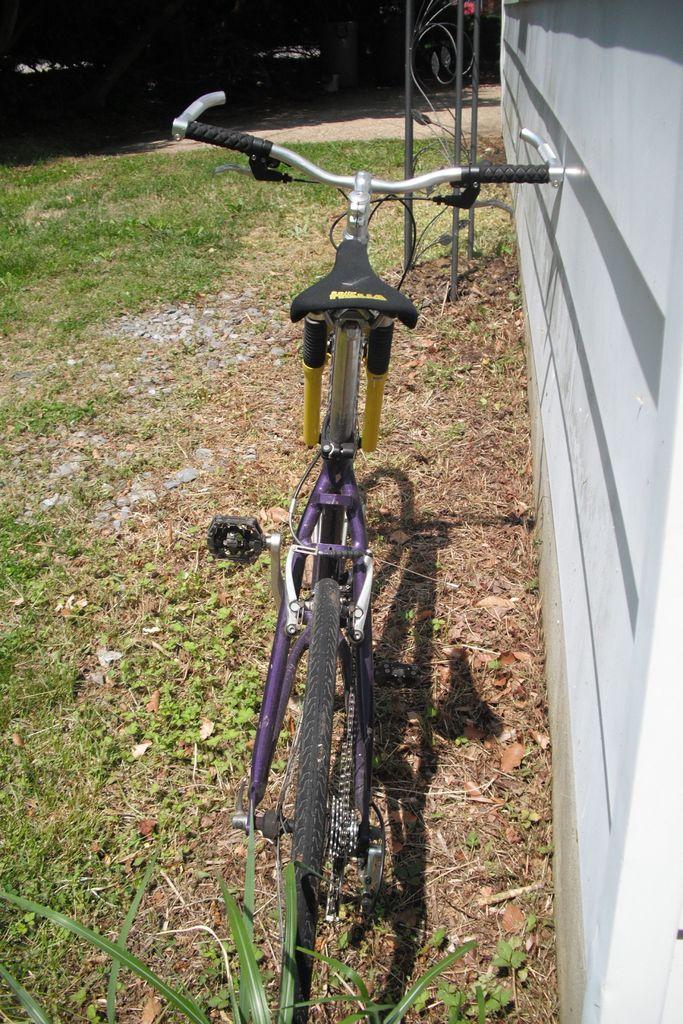In one or two sentences, can you explain what this image depicts? On this surface there is a grass. Beside this wall we can see bicycle. In-front of this bicycle there are rods.  